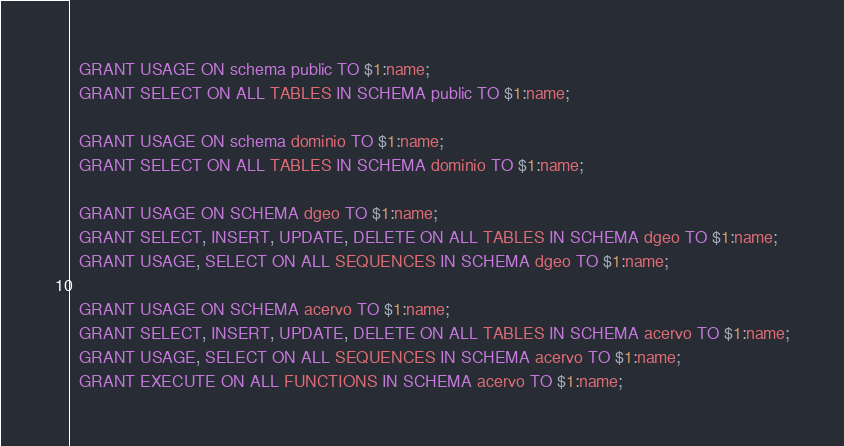<code> <loc_0><loc_0><loc_500><loc_500><_SQL_>  GRANT USAGE ON schema public TO $1:name;
  GRANT SELECT ON ALL TABLES IN SCHEMA public TO $1:name;

  GRANT USAGE ON schema dominio TO $1:name;
  GRANT SELECT ON ALL TABLES IN SCHEMA dominio TO $1:name;

  GRANT USAGE ON SCHEMA dgeo TO $1:name;
  GRANT SELECT, INSERT, UPDATE, DELETE ON ALL TABLES IN SCHEMA dgeo TO $1:name;
  GRANT USAGE, SELECT ON ALL SEQUENCES IN SCHEMA dgeo TO $1:name;

  GRANT USAGE ON SCHEMA acervo TO $1:name;
  GRANT SELECT, INSERT, UPDATE, DELETE ON ALL TABLES IN SCHEMA acervo TO $1:name;
  GRANT USAGE, SELECT ON ALL SEQUENCES IN SCHEMA acervo TO $1:name;
  GRANT EXECUTE ON ALL FUNCTIONS IN SCHEMA acervo TO $1:name;</code> 